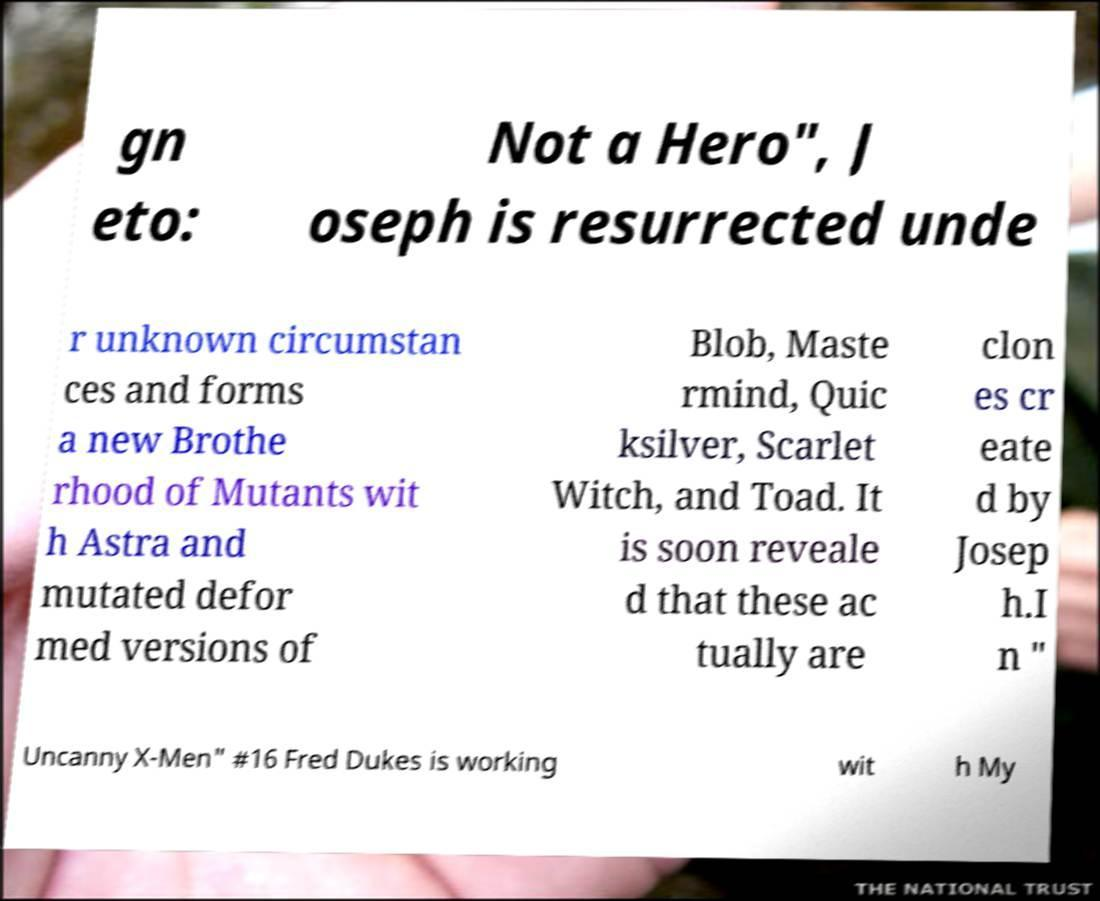There's text embedded in this image that I need extracted. Can you transcribe it verbatim? The text visible in the image reads: '[gn]eto: [Not a Hero]", [J]oseph is resurrected unde[r unknown circumstan]ces and forms a new Brothe[rhood of Mutants wit]h Astra and mutated defor[med versions of] Blob, Maste[rmind], Quic[ksilver], Scarlet Witch, and Toad. It is soon reveale[d that these ac]tually are [clon]es cr[eate]d by [Josep]h. [In "Uncanny X-Men" #16 Fred Dukes is working wit]h My'. Some parts of the text are obscured or cut off; the likely intended text is placed in brackets where it can be inferred. 